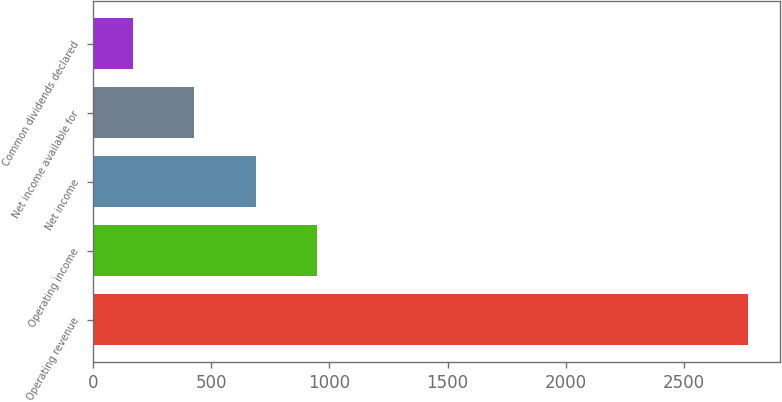Convert chart. <chart><loc_0><loc_0><loc_500><loc_500><bar_chart><fcel>Operating revenue<fcel>Operating income<fcel>Net income<fcel>Net income available for<fcel>Common dividends declared<nl><fcel>2768<fcel>949.4<fcel>689.6<fcel>429.8<fcel>170<nl></chart> 